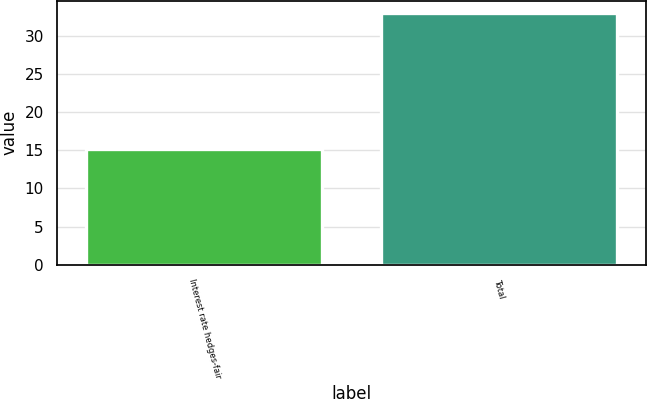Convert chart. <chart><loc_0><loc_0><loc_500><loc_500><bar_chart><fcel>Interest rate hedges-fair<fcel>Total<nl><fcel>15.2<fcel>33<nl></chart> 